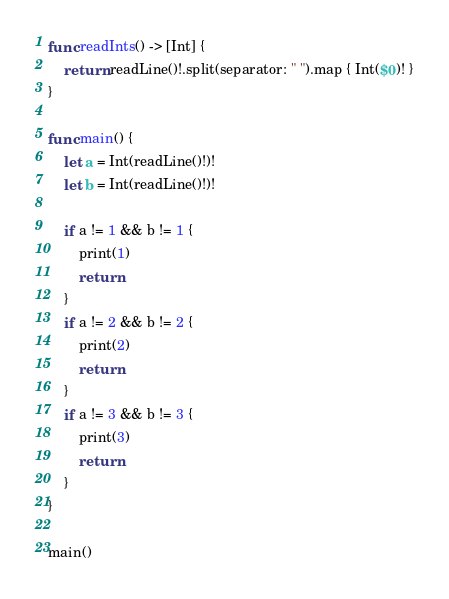<code> <loc_0><loc_0><loc_500><loc_500><_Swift_>func readInts() -> [Int] {
    return readLine()!.split(separator: " ").map { Int($0)! }
}

func main() {
    let a = Int(readLine()!)!
    let b = Int(readLine()!)!
    
    if a != 1 && b != 1 {
        print(1)
        return
    }
    if a != 2 && b != 2 {
        print(2)
        return
    }
    if a != 3 && b != 3 {
        print(3)
        return
    }
}

main()
</code> 